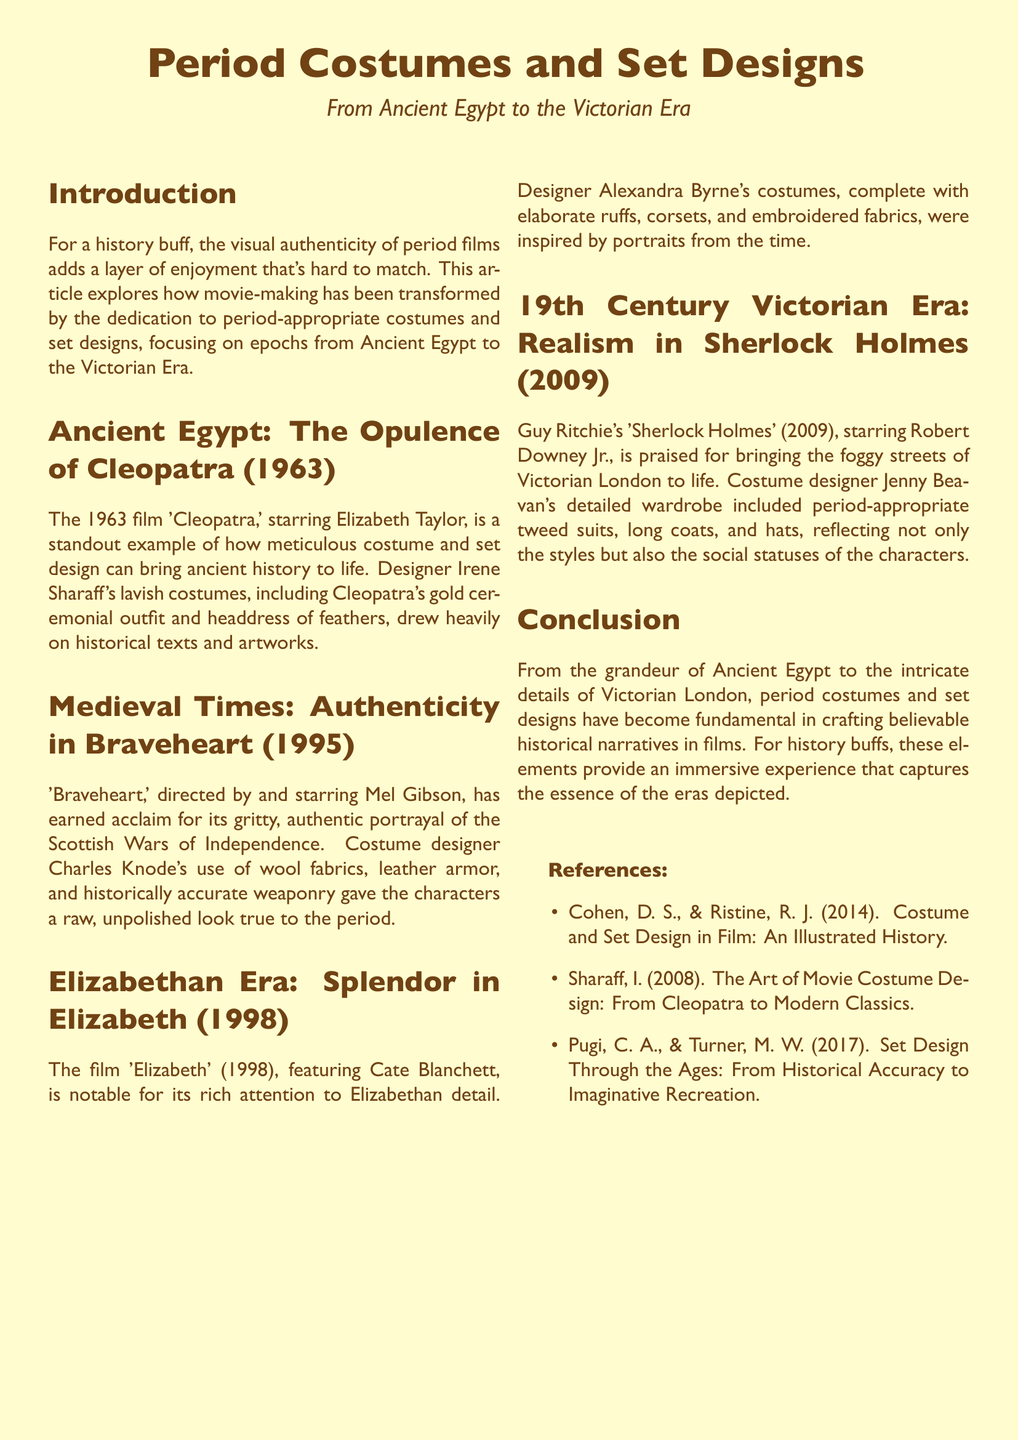What film features Elizabeth Taylor as Cleopatra? The document specifies that the film 'Cleopatra' (1963) stars Elizabeth Taylor.
Answer: Cleopatra (1963) Who designed the costumes for 'Braveheart'? The document attributes the costume design of 'Braveheart' to Charles Knode.
Answer: Charles Knode What period is depicted in the film 'Elizabeth'? According to the document, 'Elizabeth' (1998) represents the Elizabethan Era.
Answer: Elizabethan Era Which designer created the costumes for 'Sherlock Holmes'? The document names Jenny Beavan as the costume designer for 'Sherlock Holmes' (2009).
Answer: Jenny Beavan What era does the conclusion mention as the last discussed? The conclusion mentions the Victorian Era as the last discussed era in the document.
Answer: Victorian Era What is a key feature of the costumes in 'Elizabeth'? The document highlights elaborate ruffs as a key feature of the costumes in 'Elizabeth'.
Answer: Elaborate ruffs What type of historical accuracy is stressed in 'Braveheart'? The document emphasizes authenticity in the portrayal of the Scottish Wars of Independence in 'Braveheart'.
Answer: Authenticity What does the introduction express is important for history buffs? The introduction states that visual authenticity in period films is an important aspect for history buffs.
Answer: Visual authenticity 